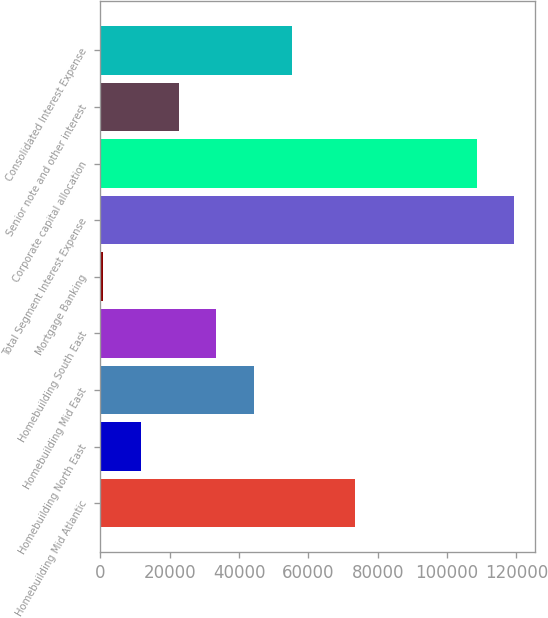Convert chart. <chart><loc_0><loc_0><loc_500><loc_500><bar_chart><fcel>Homebuilding Mid Atlantic<fcel>Homebuilding North East<fcel>Homebuilding Mid East<fcel>Homebuilding South East<fcel>Mortgage Banking<fcel>Total Segment Interest Expense<fcel>Corporate capital allocation<fcel>Senior note and other interest<fcel>Consolidated Interest Expense<nl><fcel>73441<fcel>11653.4<fcel>44351.6<fcel>33452.2<fcel>754<fcel>119408<fcel>108509<fcel>22552.8<fcel>55251<nl></chart> 